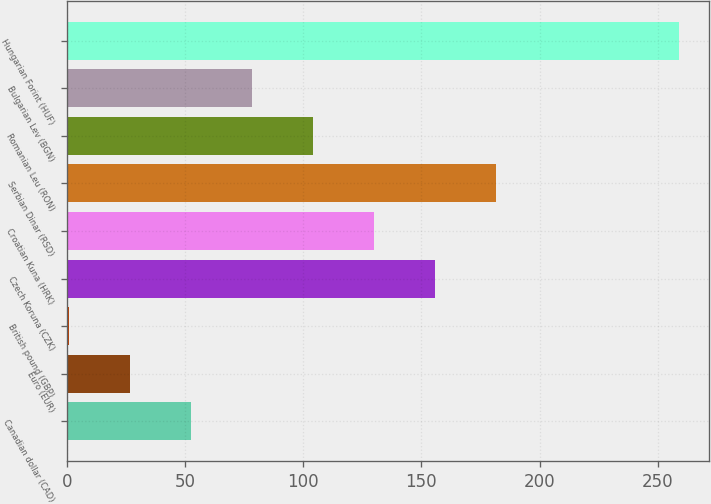Convert chart to OTSL. <chart><loc_0><loc_0><loc_500><loc_500><bar_chart><fcel>Canadian dollar (CAD)<fcel>Euro (EUR)<fcel>British pound (GBP)<fcel>Czech Koruna (CZK)<fcel>Croatian Kuna (HRK)<fcel>Serbian Dinar (RSD)<fcel>Romanian Leu (RON)<fcel>Bulgarian Lev (BGN)<fcel>Hungarian Forint (HUF)<nl><fcel>52.38<fcel>26.56<fcel>0.74<fcel>155.66<fcel>129.84<fcel>181.48<fcel>104.02<fcel>78.2<fcel>258.91<nl></chart> 